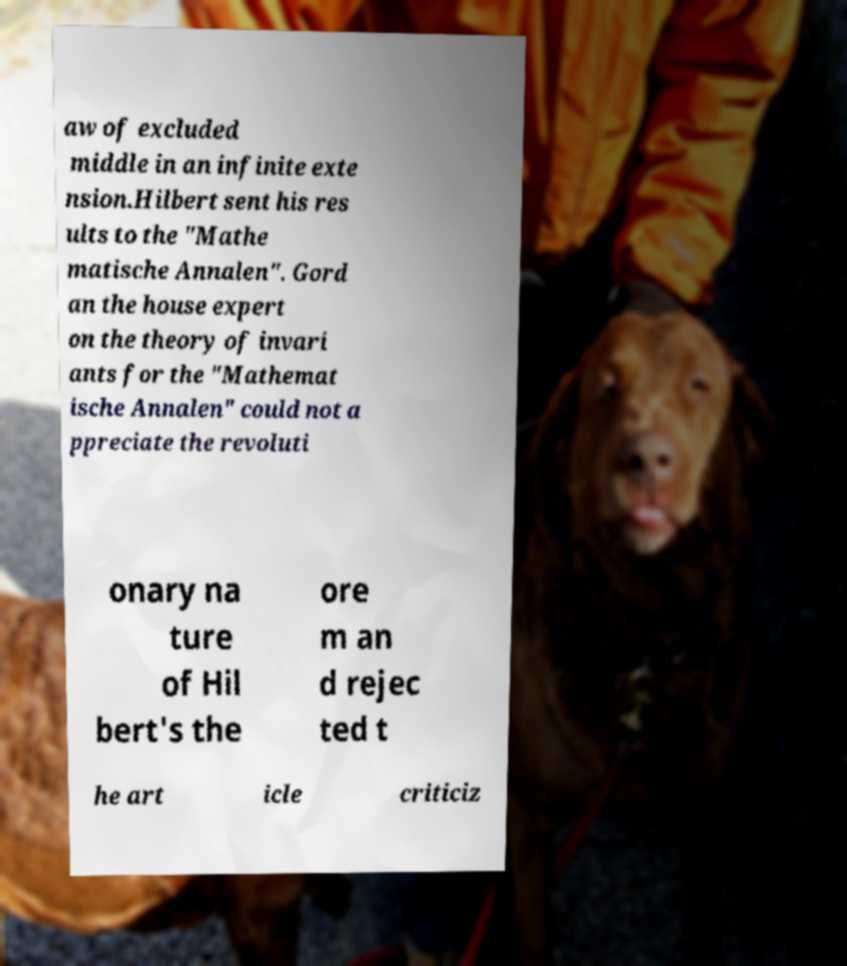Can you read and provide the text displayed in the image?This photo seems to have some interesting text. Can you extract and type it out for me? aw of excluded middle in an infinite exte nsion.Hilbert sent his res ults to the "Mathe matische Annalen". Gord an the house expert on the theory of invari ants for the "Mathemat ische Annalen" could not a ppreciate the revoluti onary na ture of Hil bert's the ore m an d rejec ted t he art icle criticiz 